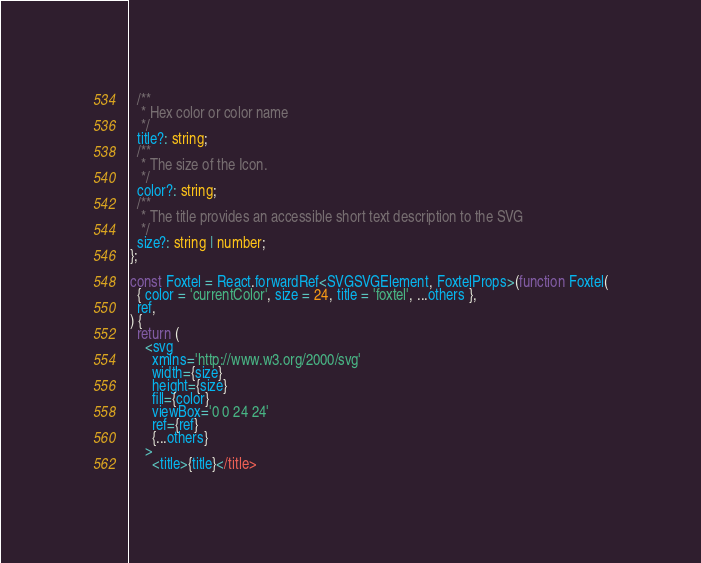<code> <loc_0><loc_0><loc_500><loc_500><_TypeScript_>  /**
   * Hex color or color name
   */
  title?: string;
  /**
   * The size of the Icon.
   */
  color?: string;
  /**
   * The title provides an accessible short text description to the SVG
   */
  size?: string | number;
};

const Foxtel = React.forwardRef<SVGSVGElement, FoxtelProps>(function Foxtel(
  { color = 'currentColor', size = 24, title = 'foxtel', ...others },
  ref,
) {
  return (
    <svg
      xmlns='http://www.w3.org/2000/svg'
      width={size}
      height={size}
      fill={color}
      viewBox='0 0 24 24'
      ref={ref}
      {...others}
    >
      <title>{title}</title></code> 